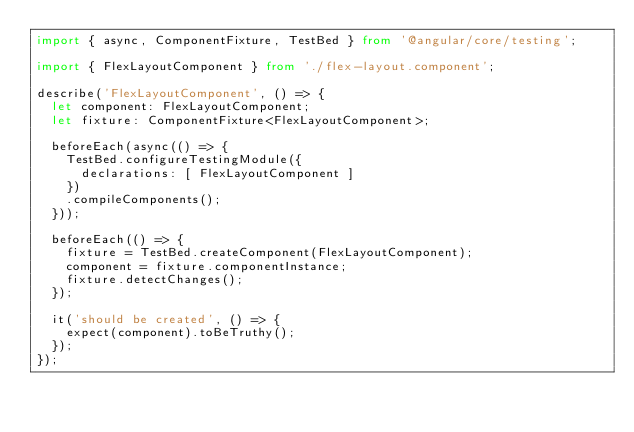Convert code to text. <code><loc_0><loc_0><loc_500><loc_500><_TypeScript_>import { async, ComponentFixture, TestBed } from '@angular/core/testing';

import { FlexLayoutComponent } from './flex-layout.component';

describe('FlexLayoutComponent', () => {
  let component: FlexLayoutComponent;
  let fixture: ComponentFixture<FlexLayoutComponent>;

  beforeEach(async(() => {
    TestBed.configureTestingModule({
      declarations: [ FlexLayoutComponent ]
    })
    .compileComponents();
  }));

  beforeEach(() => {
    fixture = TestBed.createComponent(FlexLayoutComponent);
    component = fixture.componentInstance;
    fixture.detectChanges();
  });

  it('should be created', () => {
    expect(component).toBeTruthy();
  });
});
</code> 